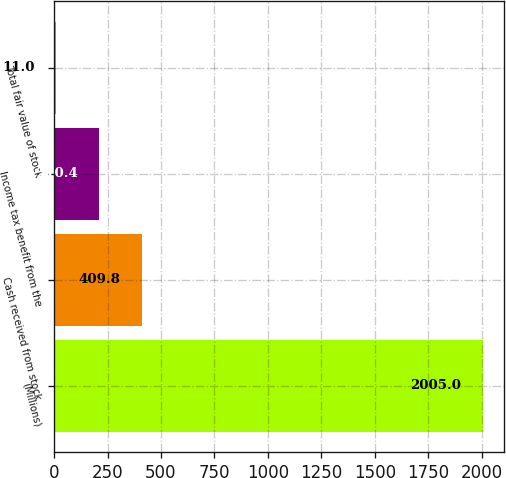Convert chart. <chart><loc_0><loc_0><loc_500><loc_500><bar_chart><fcel>(Millions)<fcel>Cash received from stock<fcel>Income tax benefit from the<fcel>Total fair value of stock<nl><fcel>2005<fcel>409.8<fcel>210.4<fcel>11<nl></chart> 